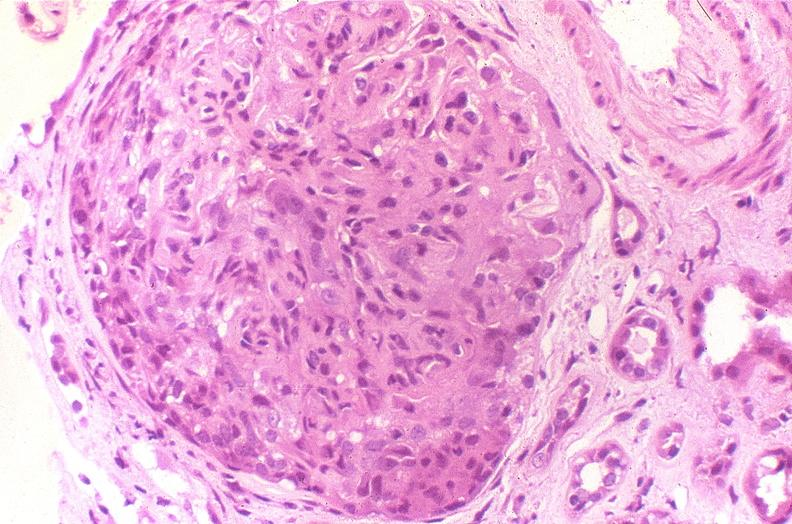where is this?
Answer the question using a single word or phrase. Urinary 